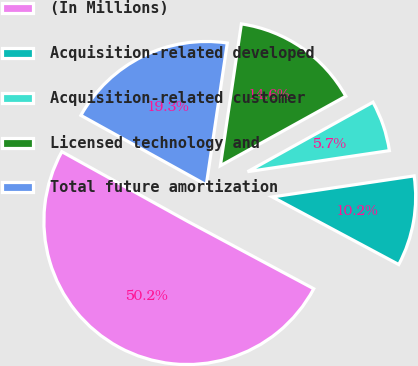Convert chart. <chart><loc_0><loc_0><loc_500><loc_500><pie_chart><fcel>(In Millions)<fcel>Acquisition-related developed<fcel>Acquisition-related customer<fcel>Licensed technology and<fcel>Total future amortization<nl><fcel>50.24%<fcel>10.16%<fcel>5.71%<fcel>14.61%<fcel>19.29%<nl></chart> 